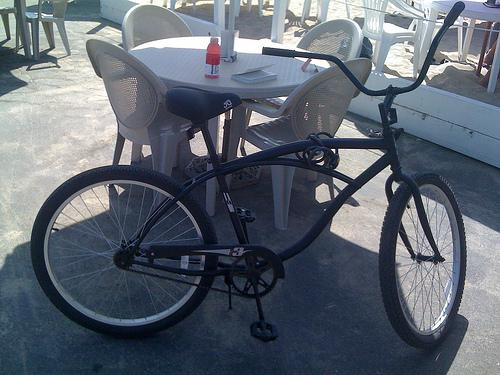Question: how is the bike standing?
Choices:
A. It's being held by a person.
B. The kickstand.
C. It's leaning on a wall.
D. It's leaning on a bench.
Answer with the letter. Answer: B Question: how many bikes are there?
Choices:
A. One.
B. Two.
C. Three.
D. Four.
Answer with the letter. Answer: A Question: how many chairs are at the table?
Choices:
A. Three.
B. Two.
C. Four.
D. Six.
Answer with the letter. Answer: C Question: where is the bike?
Choices:
A. By the person.
B. In the garage.
C. Under the tree.
D. In front of the table.
Answer with the letter. Answer: D Question: what , other than the bottle, is on the table?
Choices:
A. A book.
B. A bottle.
C. A glass.
D. A vase.
Answer with the letter. Answer: A 